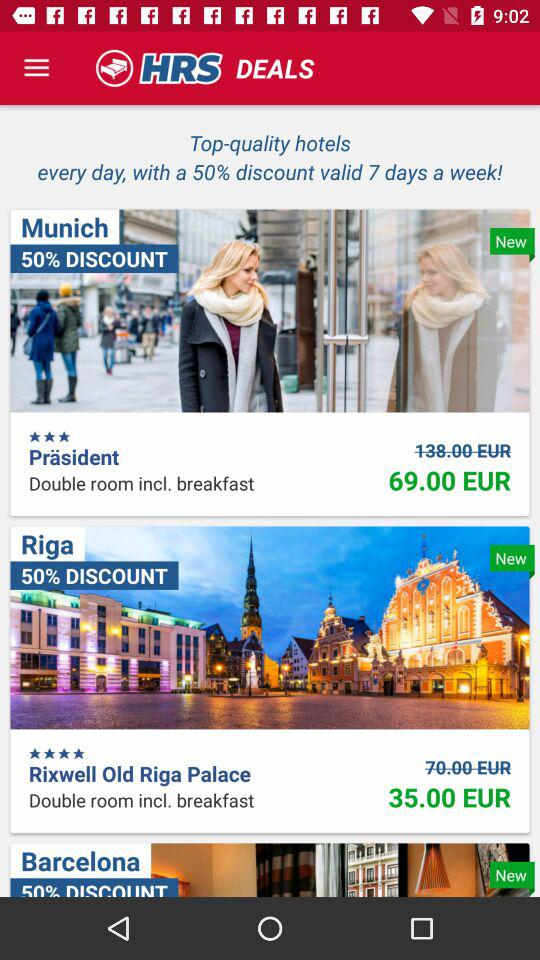What does the "Präsident" hotel offer? The "Präsident" hotel offers a double room, including breakfast. 